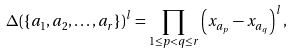Convert formula to latex. <formula><loc_0><loc_0><loc_500><loc_500>& \Delta ( \{ a _ { 1 } , a _ { 2 } , \dots , a _ { r } \} ) ^ { l } = \prod _ { 1 \leq p < q \leq r } \left ( x _ { a _ { p } } - x _ { a _ { q } } \right ) ^ { l } ,</formula> 